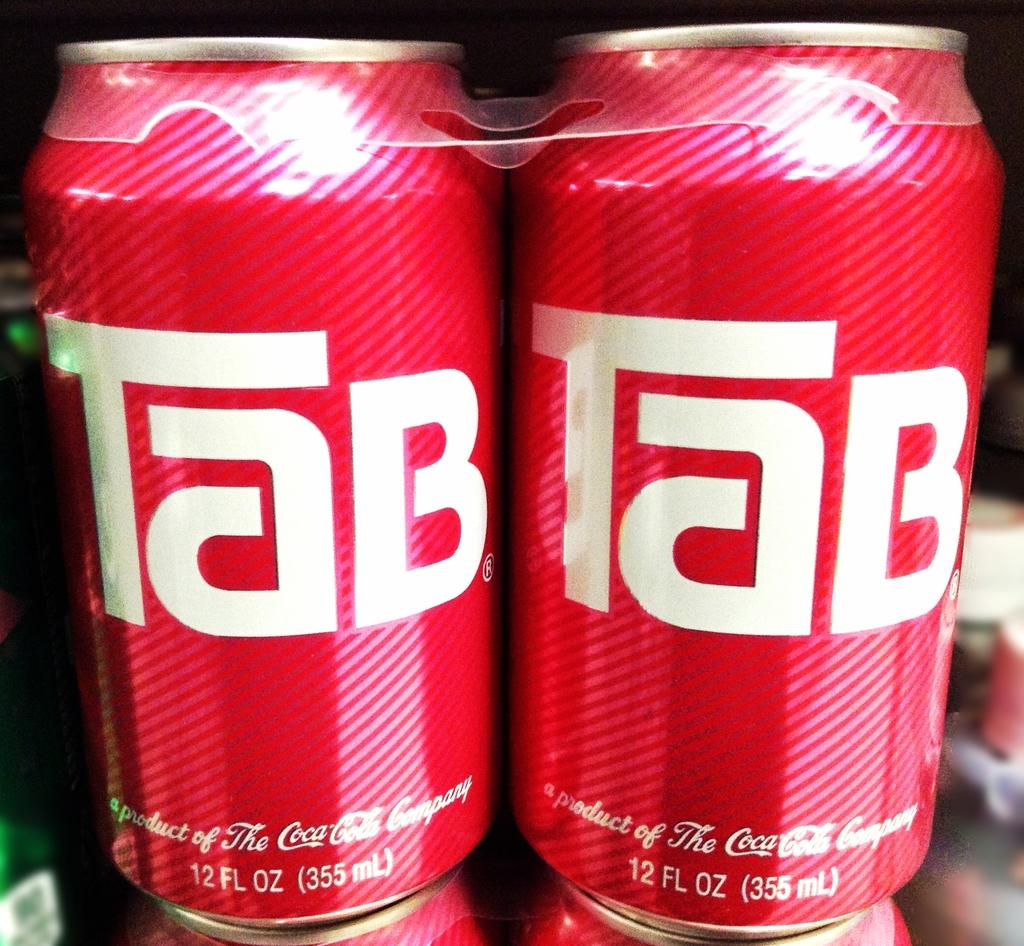Provide a one-sentence caption for the provided image. The can of Tab soda is from Coca-Cola. 